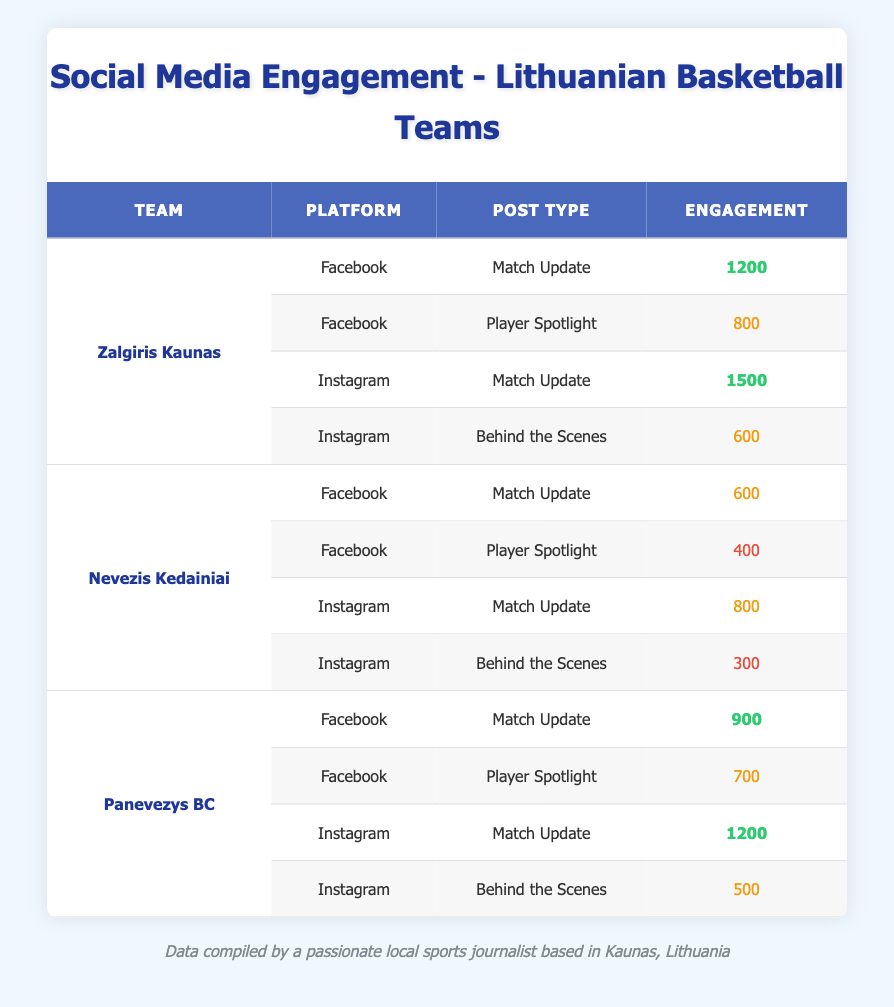What's the engagement for the Match Update post type on Facebook for Zalgiris Kaunas? The table shows that Zalgiris Kaunas has an engagement of 1200 for the Match Update post type on Facebook.
Answer: 1200 Which platform had the highest engagement for Zalgiris Kaunas? The table indicates that Zalgiris Kaunas had the highest engagement of 1500 for the Match Update post type on Instagram.
Answer: Instagram What is the total engagement from all platforms for Nevezis Kedainiai? The total engagement can be calculated by adding the engagement values for Nevezis Kedainiai: 600 (Facebook Match Update) + 400 (Facebook Player Spotlight) + 800 (Instagram Match Update) + 300 (Instagram Behind the Scenes) = 2100.
Answer: 2100 Which team had the lowest engagement for the Player Spotlight post type? Nevezis Kedainiai had the lowest engagement for the Player Spotlight post type with an engagement value of 400, compared to 700 for Panevezys BC and 800 for Zalgiris Kaunas.
Answer: Nevezis Kedainiai Is it true that Panevezys BC received higher engagement than Nevezis Kedainiai on Instagram for Match Updates? In the table, Panevezys BC has an engagement of 1200 for Match Updates on Instagram, while Nevezis Kedainiai has 800 for the same post type on Instagram. Therefore, it is true that Panevezys BC received higher engagement.
Answer: Yes What is the difference in engagement between the highest and lowest engagement post types for Zalgiris Kaunas? The highest engagement post type for Zalgiris Kaunas is the Match Update on Instagram with 1500, and the lowest is Behind the Scenes on Instagram with 600. The difference is 1500 - 600 = 900.
Answer: 900 On which platform did Panevezys BC have a higher engagement: Facebook or Instagram? For Panevezys BC, the engagement on Facebook for Match Update is 900 and for Player Spotlight is 700, totaling 1600. On Instagram, the Match Update had 1200 and Behind the Scenes had 500, totaling 1700. Therefore, Panevezys BC had higher engagement on Instagram.
Answer: Instagram What was the total engagement for all post types on Facebook across all teams? To calculate the total engagement on Facebook, we add: 1200 (Zalgiris Kaunas Match Update) + 800 (Zalgiris Kaunas Player Spotlight) + 600 (Nevezis Kedainiai Match Update) + 400 (Nevezis Kedainiai Player Spotlight) + 900 (Panevezys BC Match Update) + 700 (Panevezys BC Player Spotlight) = 3900.
Answer: 3900 Which post type on Instagram had the lowest engagement across all teams? According to the table, the lowest engagement for Instagram is 300, which belongs to Nevezis Kedainiai for the Behind the Scenes post type.
Answer: Behind the Scenes 